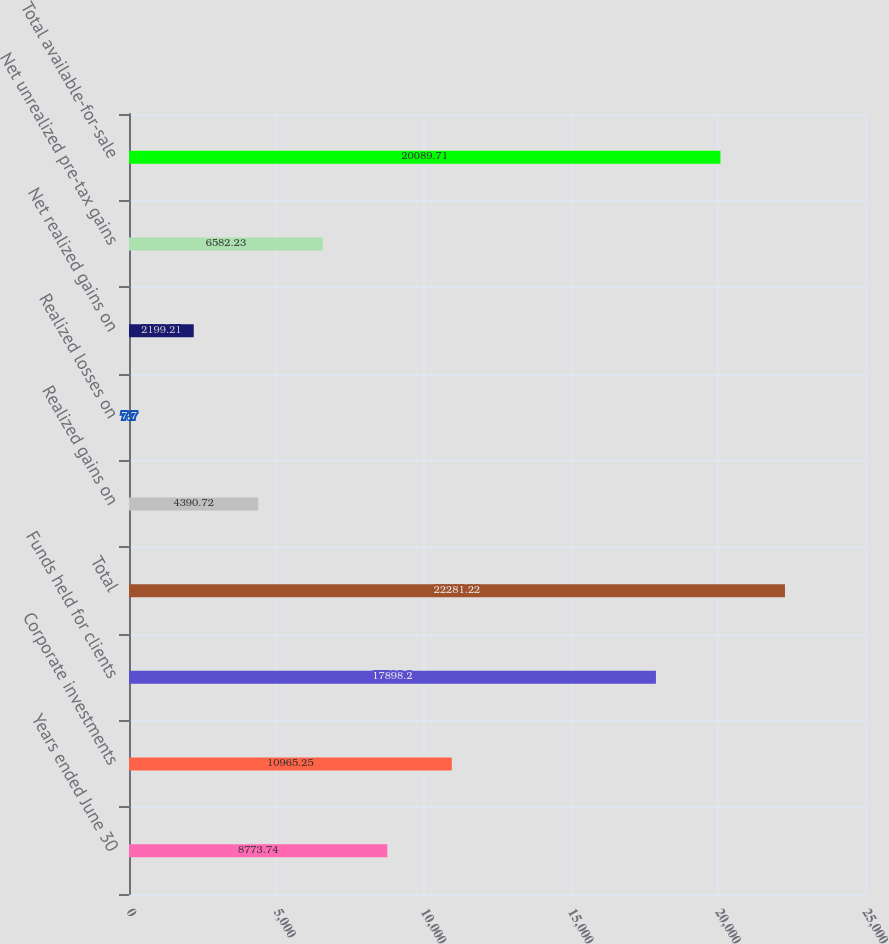Convert chart to OTSL. <chart><loc_0><loc_0><loc_500><loc_500><bar_chart><fcel>Years ended June 30<fcel>Corporate investments<fcel>Funds held for clients<fcel>Total<fcel>Realized gains on<fcel>Realized losses on<fcel>Net realized gains on<fcel>Net unrealized pre-tax gains<fcel>Total available-for-sale<nl><fcel>8773.74<fcel>10965.2<fcel>17898.2<fcel>22281.2<fcel>4390.72<fcel>7.7<fcel>2199.21<fcel>6582.23<fcel>20089.7<nl></chart> 